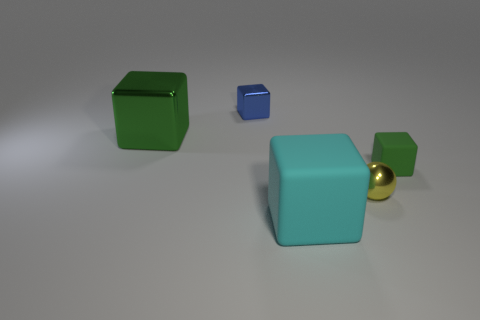Is the tiny rubber cube the same color as the big metallic block?
Provide a short and direct response. Yes. Do the small cube that is in front of the blue thing and the large object that is on the right side of the small blue metallic object have the same material?
Your answer should be compact. Yes. What size is the green metal thing?
Make the answer very short. Large. There is a blue shiny object that is the same shape as the cyan thing; what size is it?
Your response must be concise. Small. How many big things are behind the cyan cube?
Make the answer very short. 1. The large thing to the right of the block that is to the left of the blue shiny cube is what color?
Your response must be concise. Cyan. Are there any other things that have the same shape as the small yellow thing?
Offer a very short reply. No. Is the number of green cubes that are on the left side of the blue thing the same as the number of blue metallic blocks on the left side of the big rubber cube?
Provide a short and direct response. Yes. How many cubes are large yellow matte objects or large cyan objects?
Ensure brevity in your answer.  1. How many other things are the same material as the small blue thing?
Offer a terse response. 2. 